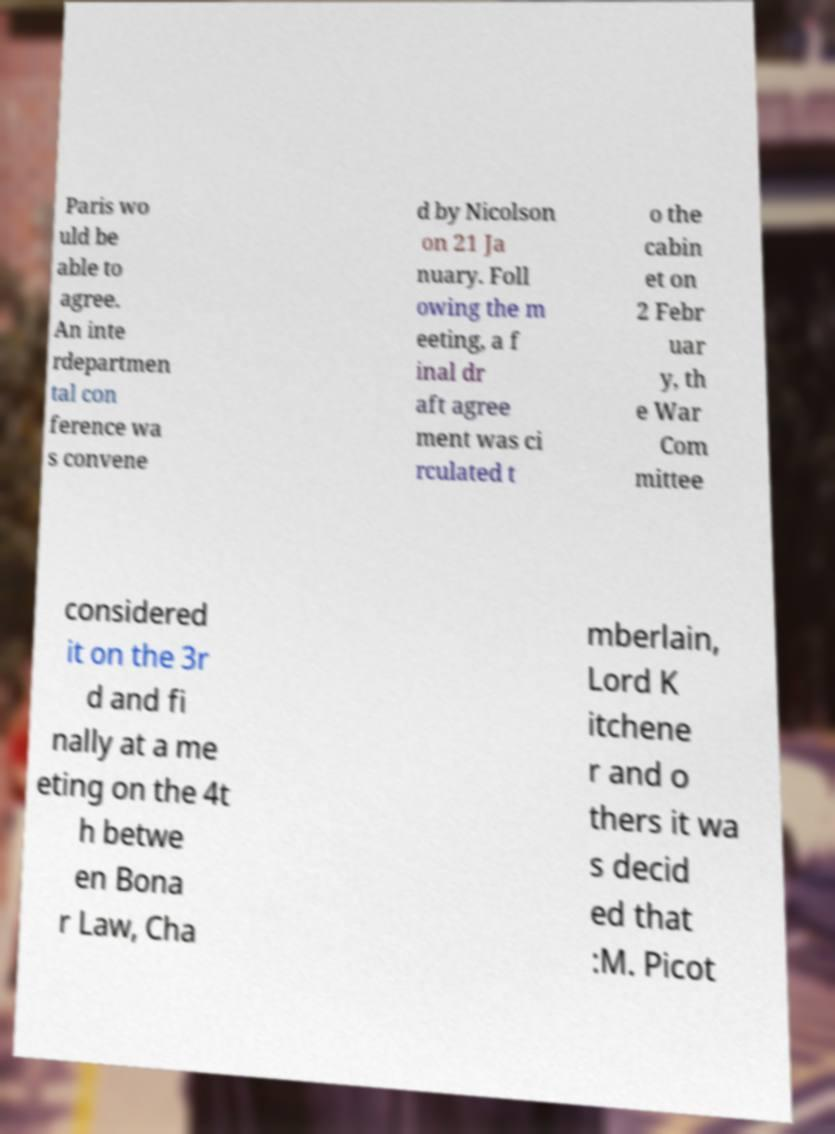I need the written content from this picture converted into text. Can you do that? Paris wo uld be able to agree. An inte rdepartmen tal con ference wa s convene d by Nicolson on 21 Ja nuary. Foll owing the m eeting, a f inal dr aft agree ment was ci rculated t o the cabin et on 2 Febr uar y, th e War Com mittee considered it on the 3r d and fi nally at a me eting on the 4t h betwe en Bona r Law, Cha mberlain, Lord K itchene r and o thers it wa s decid ed that :M. Picot 